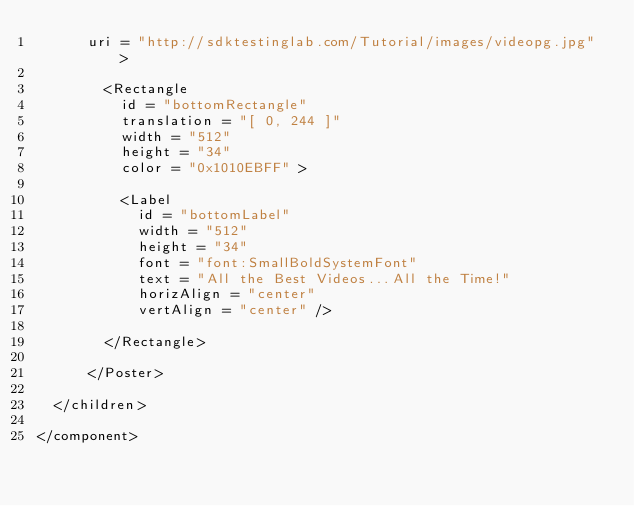Convert code to text. <code><loc_0><loc_0><loc_500><loc_500><_XML_>      uri = "http://sdktestinglab.com/Tutorial/images/videopg.jpg" >

        <Rectangle 
          id = "bottomRectangle" 
          translation = "[ 0, 244 ]" 
          width = "512" 
          height = "34" 
          color = "0x1010EBFF" >

          <Label 
            id = "bottomLabel" 
            width = "512" 
            height = "34" 
            font = "font:SmallBoldSystemFont" 
            text = "All the Best Videos...All the Time!" 
            horizAlign = "center" 
            vertAlign = "center" />

        </Rectangle>

      </Poster>

  </children>

</component>
</code> 